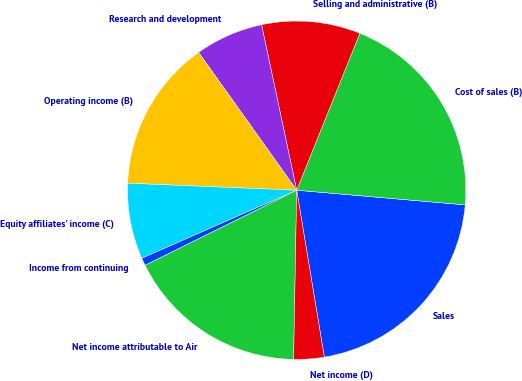Convert chart to OTSL. <chart><loc_0><loc_0><loc_500><loc_500><pie_chart><fcel>Sales<fcel>Cost of sales (B)<fcel>Selling and administrative (B)<fcel>Research and development<fcel>Operating income (B)<fcel>Equity affiliates' income (C)<fcel>Income from continuing<fcel>Net income attributable to Air<fcel>Net income (D)<nl><fcel>21.01%<fcel>20.29%<fcel>9.42%<fcel>6.52%<fcel>14.49%<fcel>7.25%<fcel>0.73%<fcel>17.39%<fcel>2.9%<nl></chart> 